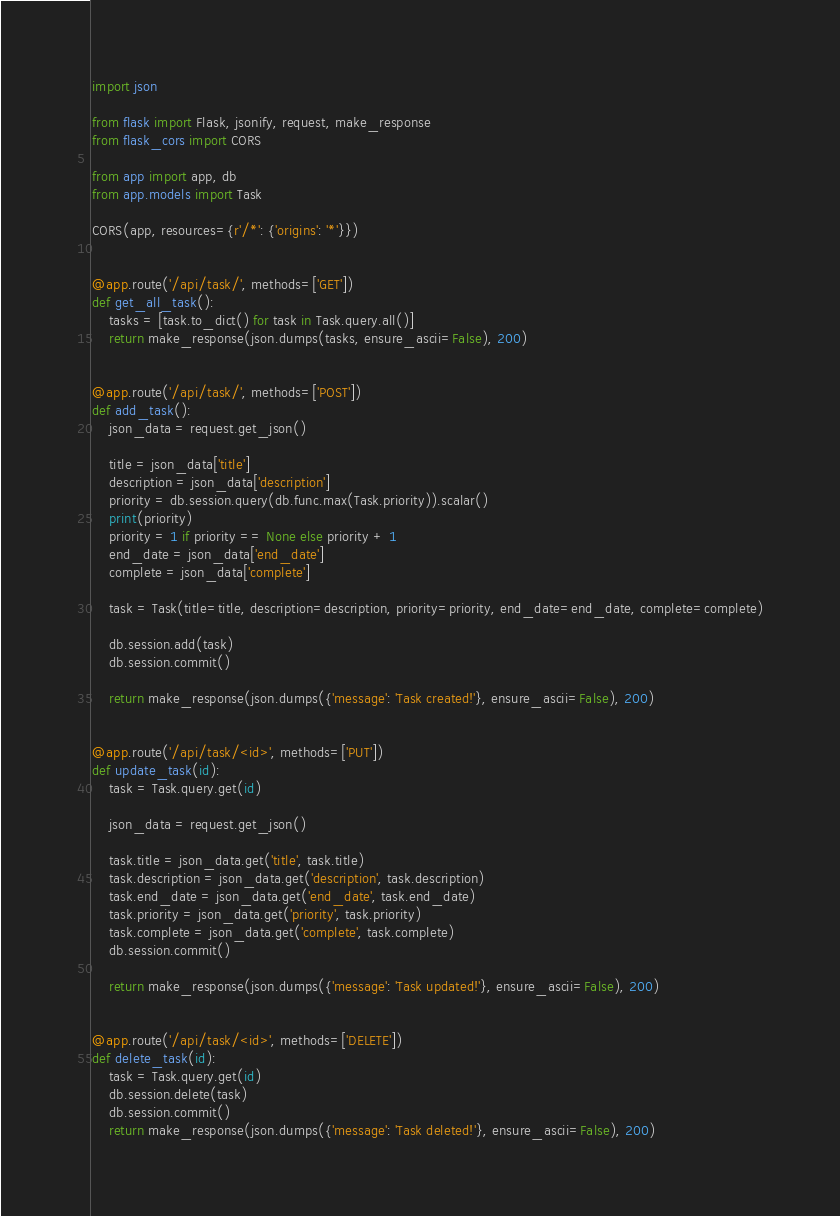<code> <loc_0><loc_0><loc_500><loc_500><_Python_>import json

from flask import Flask, jsonify, request, make_response
from flask_cors import CORS

from app import app, db
from app.models import Task

CORS(app, resources={r'/*': {'origins': '*'}})


@app.route('/api/task/', methods=['GET'])
def get_all_task():
    tasks = [task.to_dict() for task in Task.query.all()]
    return make_response(json.dumps(tasks, ensure_ascii=False), 200)


@app.route('/api/task/', methods=['POST'])
def add_task():
    json_data = request.get_json()

    title = json_data['title']
    description = json_data['description']
    priority = db.session.query(db.func.max(Task.priority)).scalar()
    print(priority)
    priority = 1 if priority == None else priority + 1
    end_date = json_data['end_date']
    complete = json_data['complete']

    task = Task(title=title, description=description, priority=priority, end_date=end_date, complete=complete)

    db.session.add(task)
    db.session.commit()

    return make_response(json.dumps({'message': 'Task created!'}, ensure_ascii=False), 200)


@app.route('/api/task/<id>', methods=['PUT'])
def update_task(id):
    task = Task.query.get(id)
    
    json_data = request.get_json()
    
    task.title = json_data.get('title', task.title)
    task.description = json_data.get('description', task.description)
    task.end_date = json_data.get('end_date', task.end_date)
    task.priority = json_data.get('priority', task.priority)
    task.complete = json_data.get('complete', task.complete)
    db.session.commit()

    return make_response(json.dumps({'message': 'Task updated!'}, ensure_ascii=False), 200)


@app.route('/api/task/<id>', methods=['DELETE'])
def delete_task(id):
    task = Task.query.get(id)
    db.session.delete(task)
    db.session.commit()
    return make_response(json.dumps({'message': 'Task deleted!'}, ensure_ascii=False), 200)
</code> 